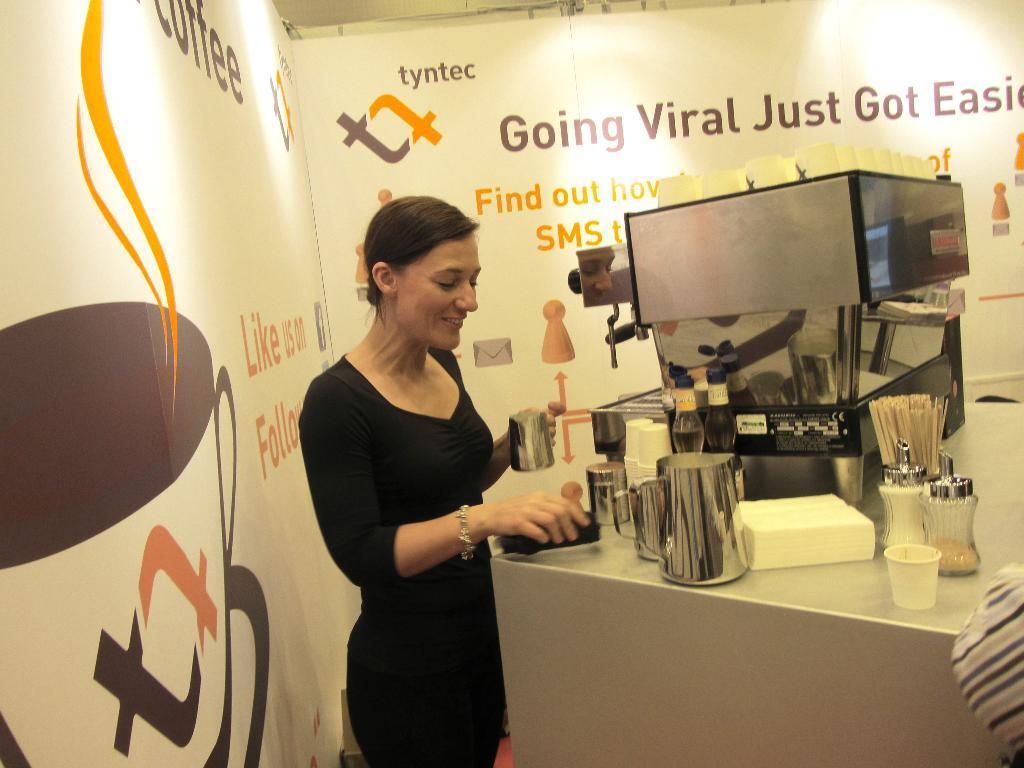Can you describe this image briefly? In the image I can see a person who is standing in front of the table on which there are some things places and to the sides there are boards on which there is some text. 